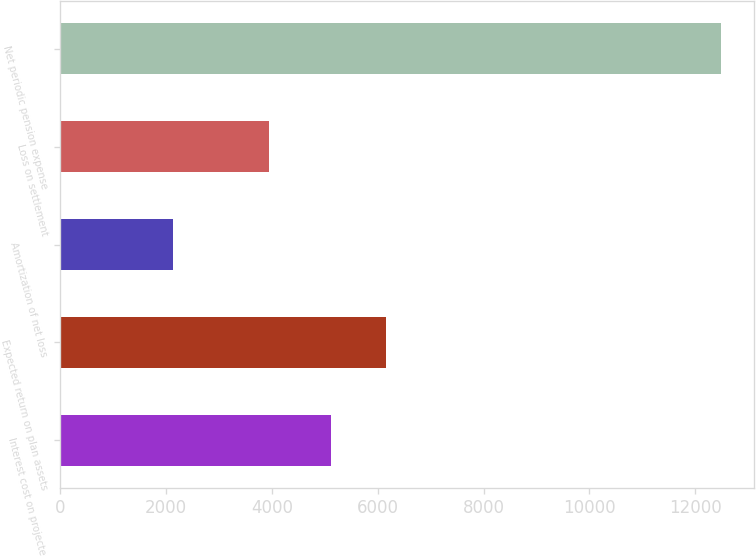<chart> <loc_0><loc_0><loc_500><loc_500><bar_chart><fcel>Interest cost on projected<fcel>Expected return on plan assets<fcel>Amortization of net loss<fcel>Loss on settlement<fcel>Net periodic pension expense<nl><fcel>5125<fcel>6162.1<fcel>2126<fcel>3951<fcel>12497<nl></chart> 